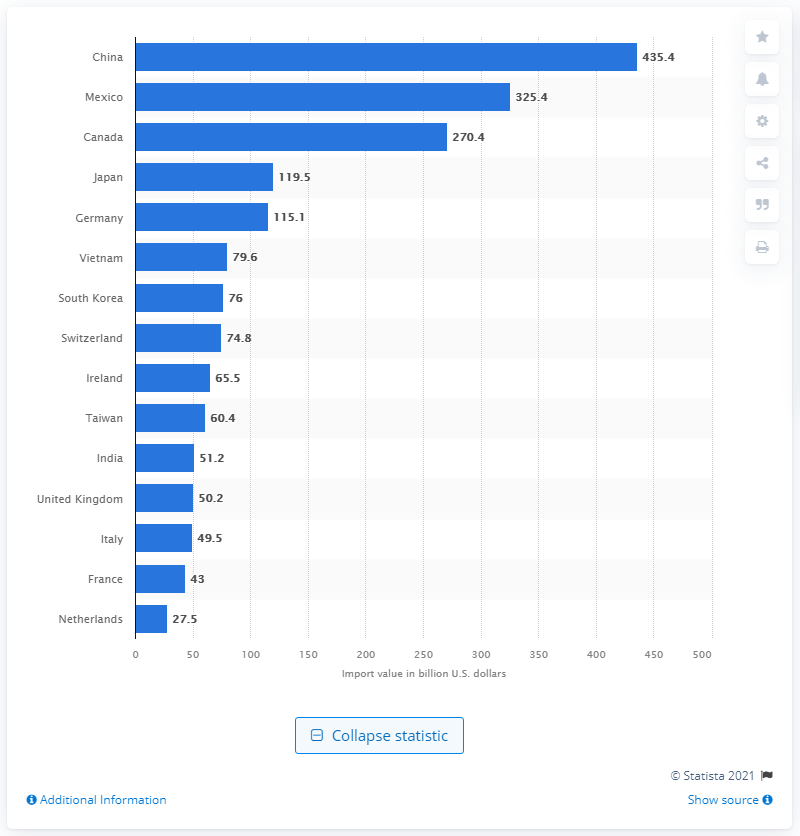Outline some significant characteristics in this image. In 2020, the United States imported a total of 435.4 billion dollars from China. The country that was the top trading partner of the United States in 2020 was China. 